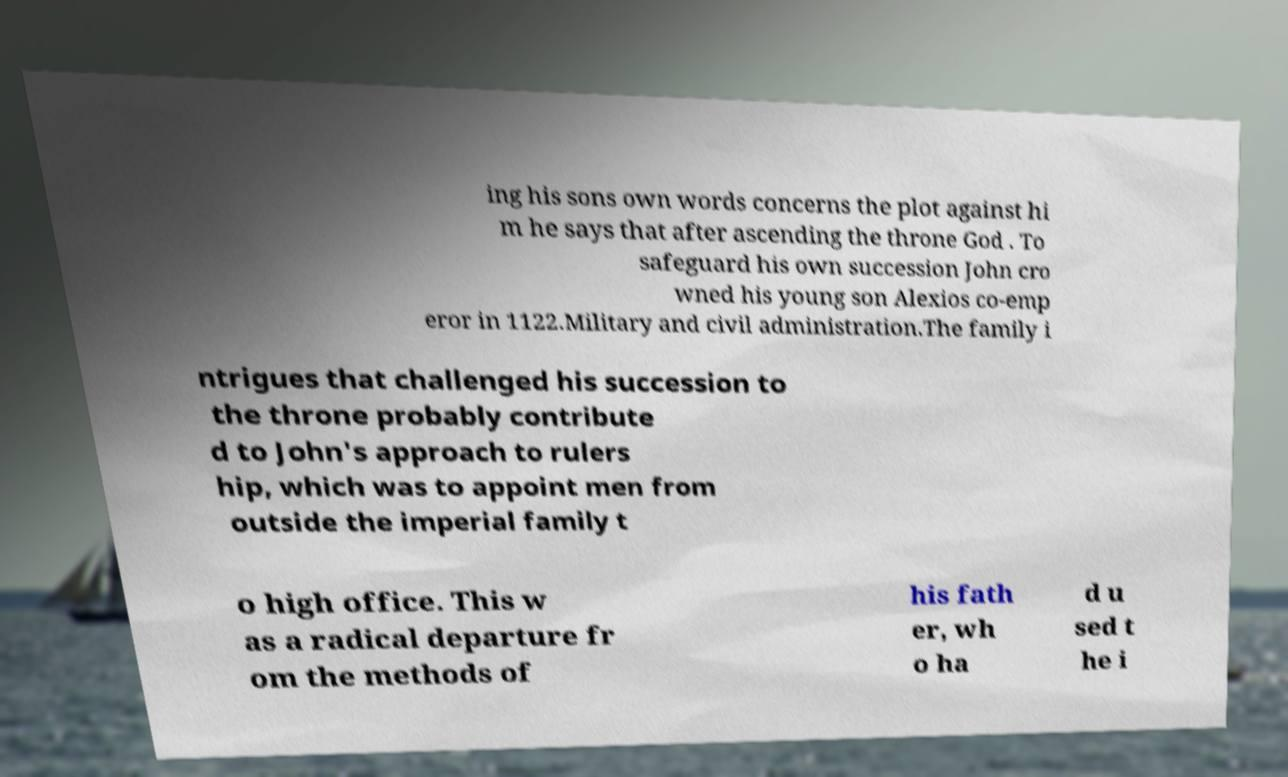Can you read and provide the text displayed in the image?This photo seems to have some interesting text. Can you extract and type it out for me? ing his sons own words concerns the plot against hi m he says that after ascending the throne God . To safeguard his own succession John cro wned his young son Alexios co-emp eror in 1122.Military and civil administration.The family i ntrigues that challenged his succession to the throne probably contribute d to John's approach to rulers hip, which was to appoint men from outside the imperial family t o high office. This w as a radical departure fr om the methods of his fath er, wh o ha d u sed t he i 